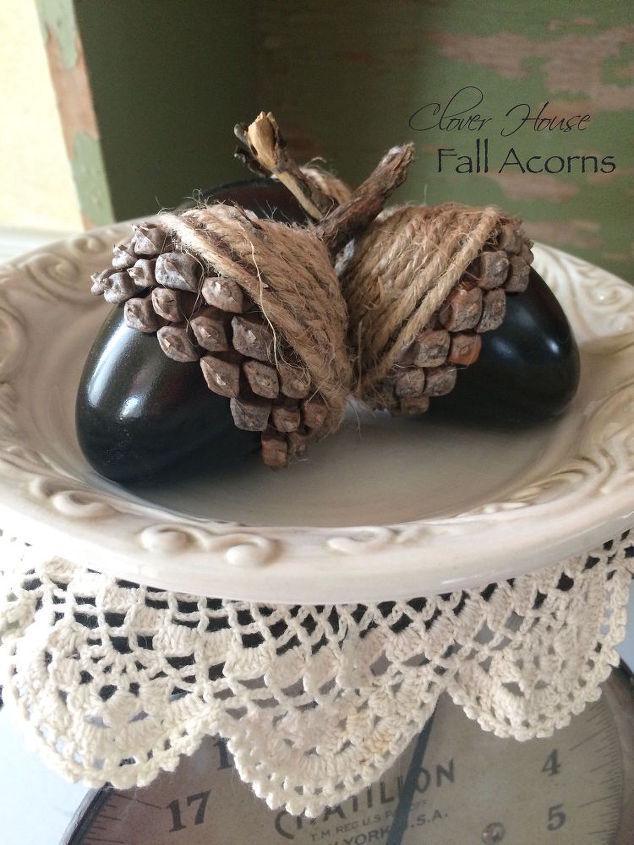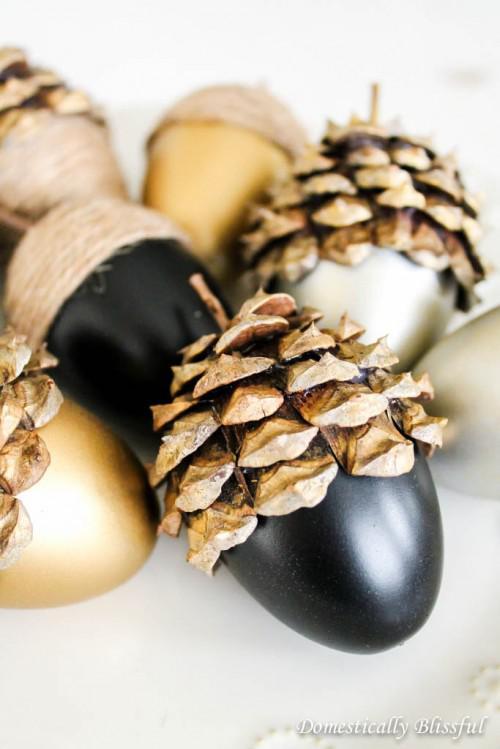The first image is the image on the left, the second image is the image on the right. Analyze the images presented: Is the assertion "The left image shows two 'acorn eggs' - one gold and one brown - in an oblong scalloped glass bowl containing smooth stones." valid? Answer yes or no. No. 